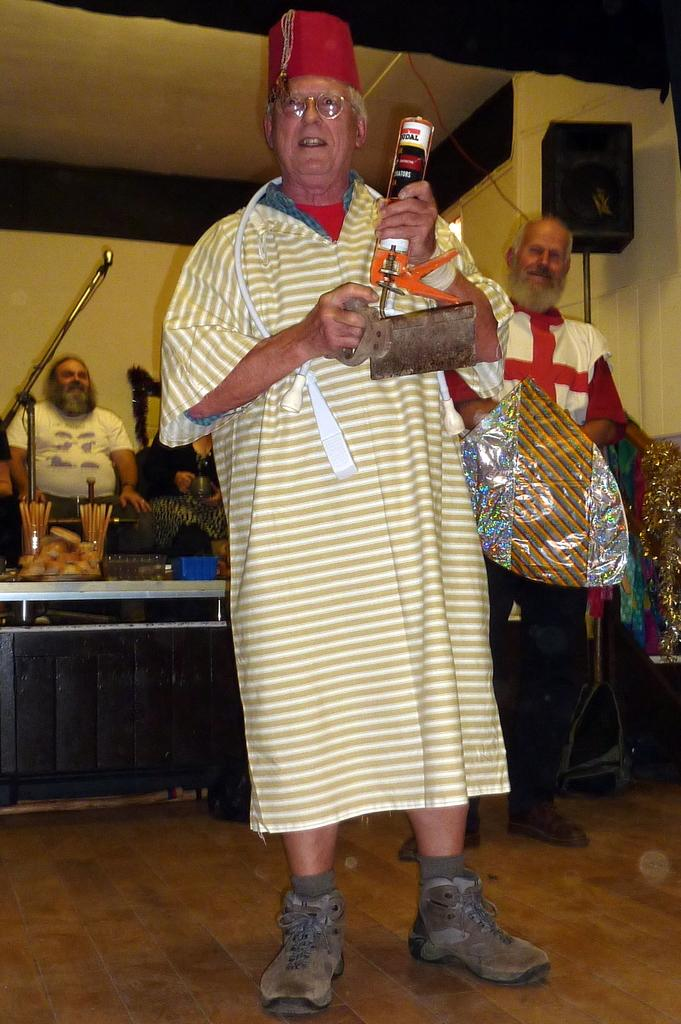How many people are in the room? There are people in the room, but the exact number is not specified. What is the person holding in the image? A person is holding an object, but the specific object is not mentioned. What piece of furniture is present in the room? There is a table in the room. What can be found on the table? There are objects on the table. What device is used for amplifying sound in the room? There is a speaker in the room. How many toes can be seen on the farmer in the image? There is no farmer present in the image, and therefore no toes can be seen. What type of team is visible in the image? There is no team present in the image. 